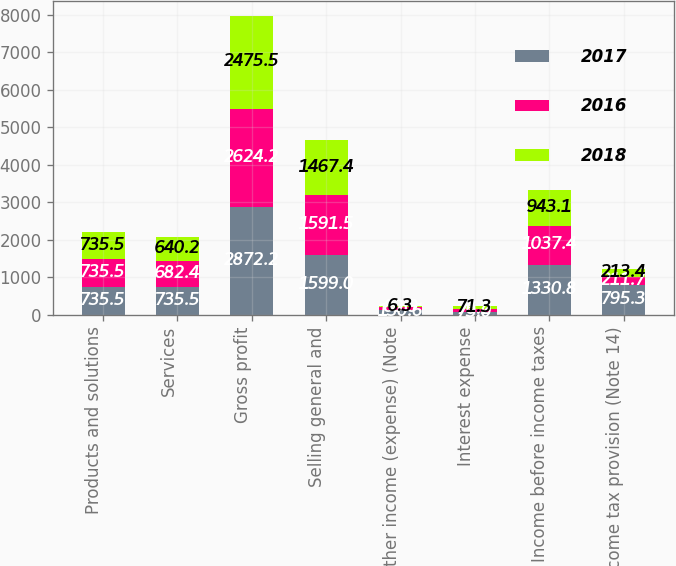Convert chart. <chart><loc_0><loc_0><loc_500><loc_500><stacked_bar_chart><ecel><fcel>Products and solutions<fcel>Services<fcel>Gross profit<fcel>Selling general and<fcel>Other income (expense) (Note<fcel>Interest expense<fcel>Income before income taxes<fcel>Income tax provision (Note 14)<nl><fcel>2017<fcel>735.5<fcel>735.5<fcel>2872.2<fcel>1599<fcel>130.6<fcel>73<fcel>1330.8<fcel>795.3<nl><fcel>2016<fcel>735.5<fcel>682.4<fcel>2624.2<fcel>1591.5<fcel>80.9<fcel>76.2<fcel>1037.4<fcel>211.7<nl><fcel>2018<fcel>735.5<fcel>640.2<fcel>2475.5<fcel>1467.4<fcel>6.3<fcel>71.3<fcel>943.1<fcel>213.4<nl></chart> 